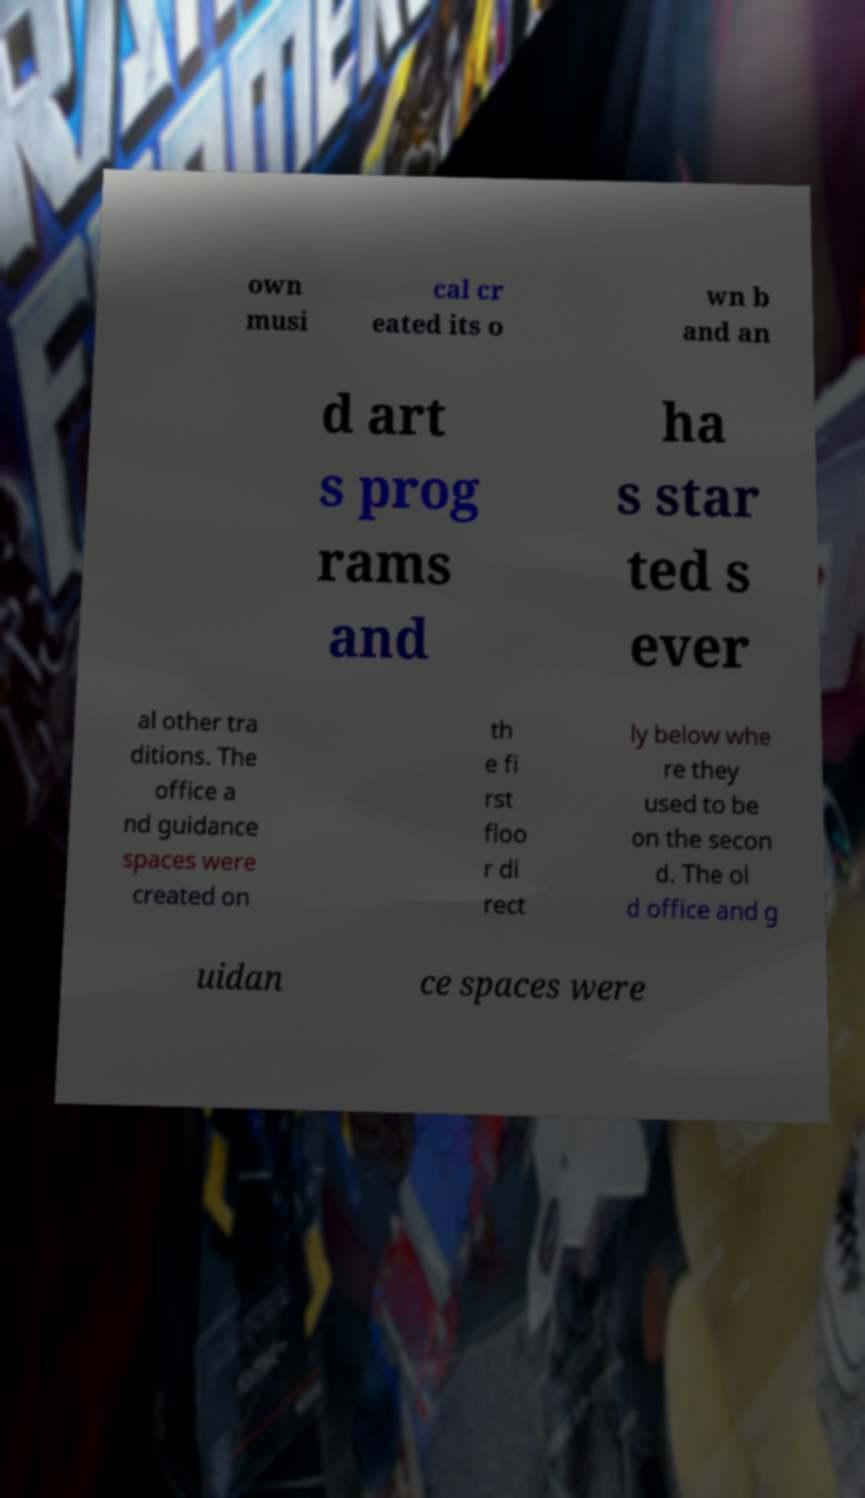I need the written content from this picture converted into text. Can you do that? own musi cal cr eated its o wn b and an d art s prog rams and ha s star ted s ever al other tra ditions. The office a nd guidance spaces were created on th e fi rst floo r di rect ly below whe re they used to be on the secon d. The ol d office and g uidan ce spaces were 